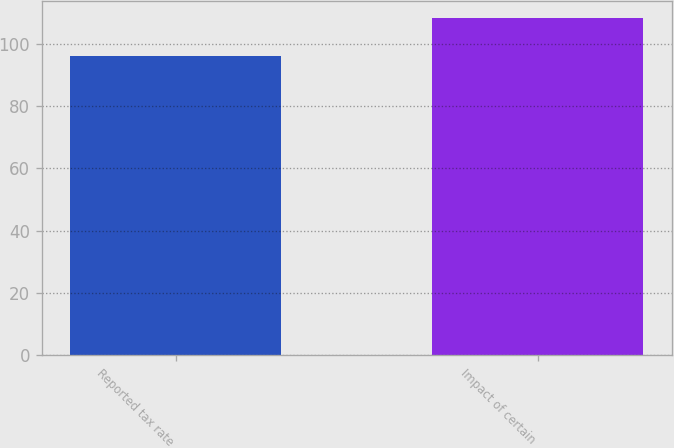<chart> <loc_0><loc_0><loc_500><loc_500><bar_chart><fcel>Reported tax rate<fcel>Impact of certain<nl><fcel>95.9<fcel>108.3<nl></chart> 